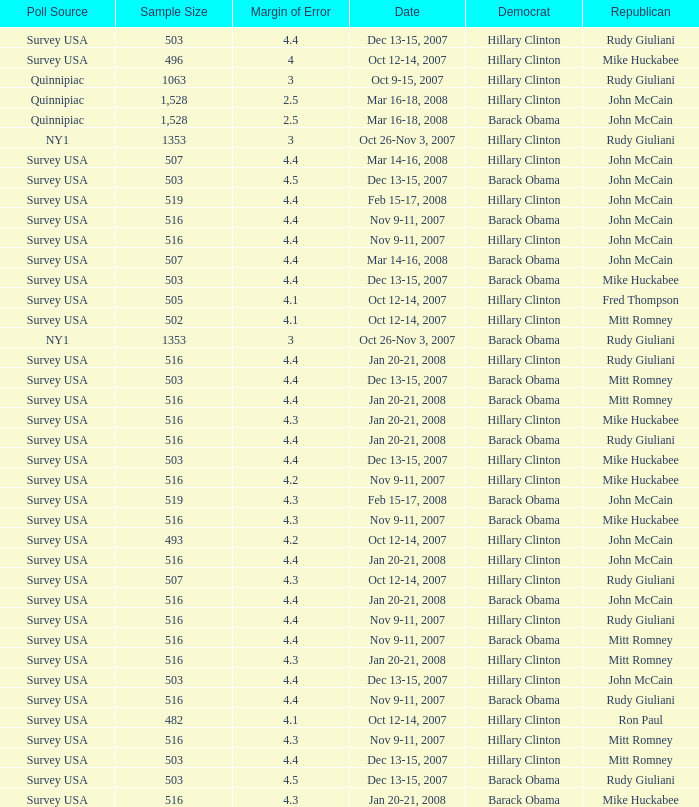Which Democrat was selected in the poll with a sample size smaller than 516 where the Republican chosen was Ron Paul? Hillary Clinton. 